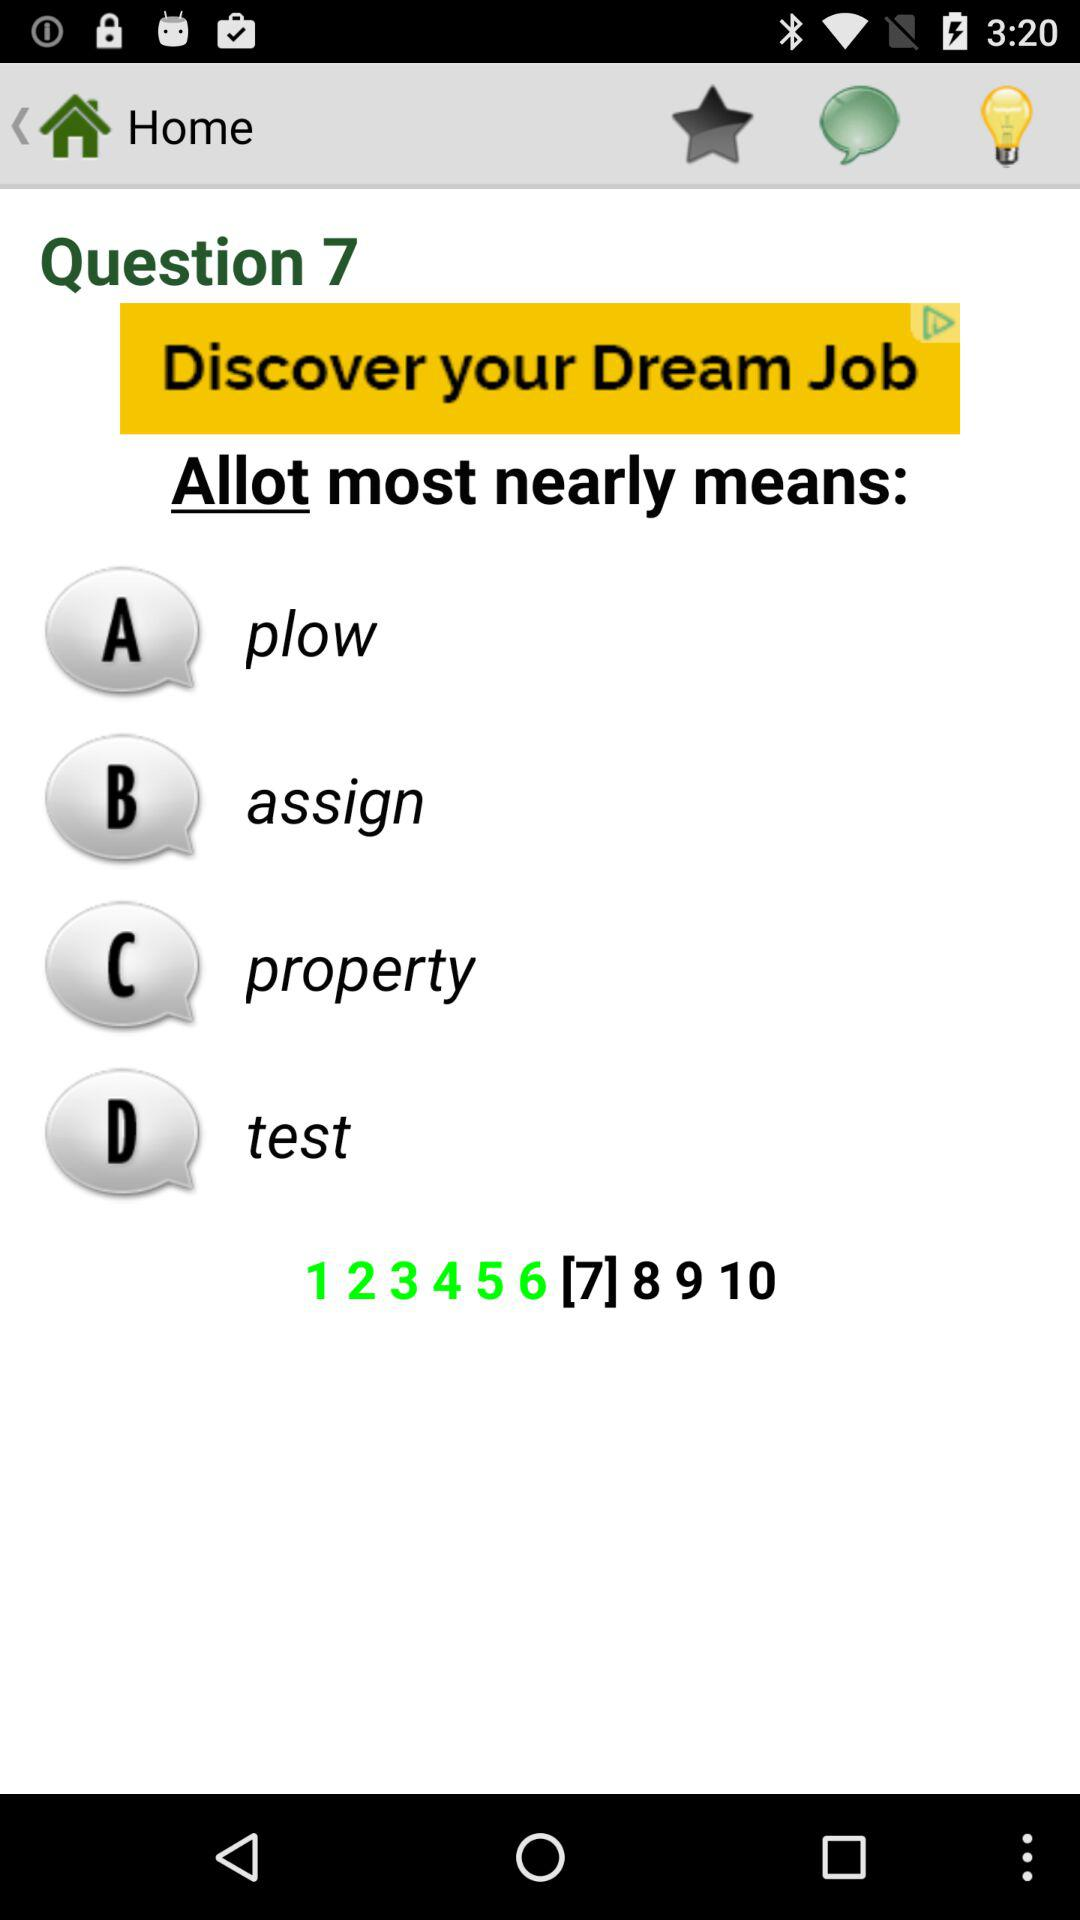At which question number is the user? The user is at the 7th question number. 